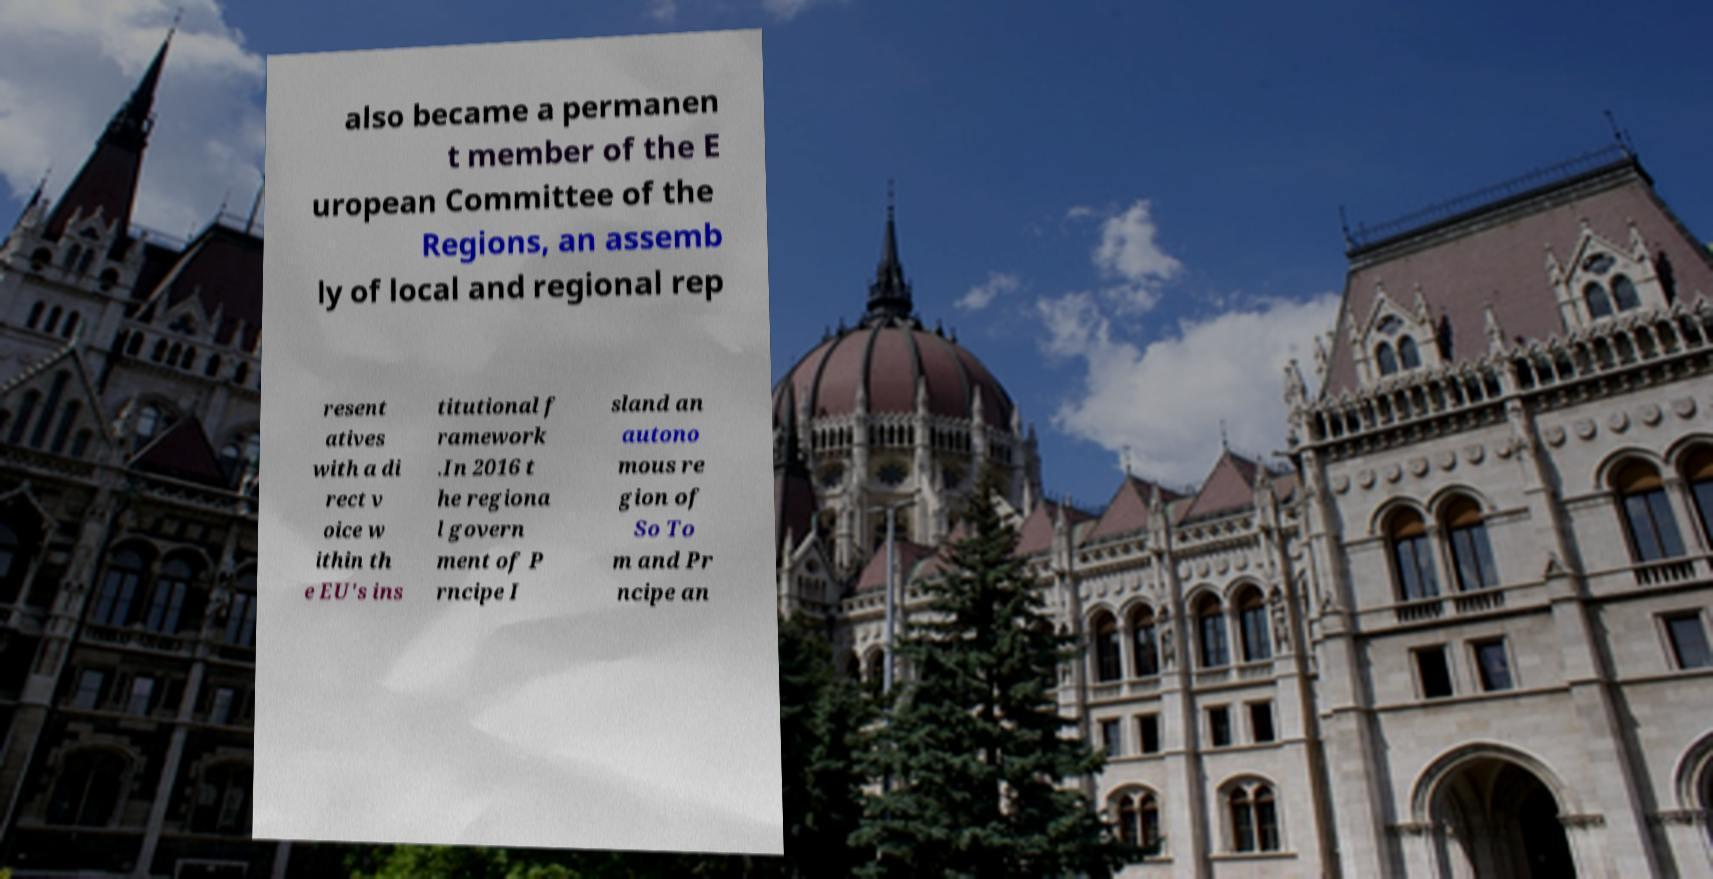There's text embedded in this image that I need extracted. Can you transcribe it verbatim? also became a permanen t member of the E uropean Committee of the Regions, an assemb ly of local and regional rep resent atives with a di rect v oice w ithin th e EU's ins titutional f ramework .In 2016 t he regiona l govern ment of P rncipe I sland an autono mous re gion of So To m and Pr ncipe an 